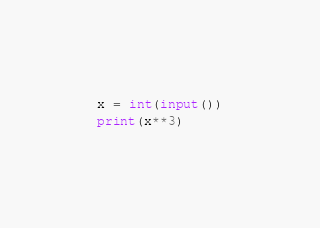Convert code to text. <code><loc_0><loc_0><loc_500><loc_500><_Python_>x = int(input())
print(x**3)
</code> 